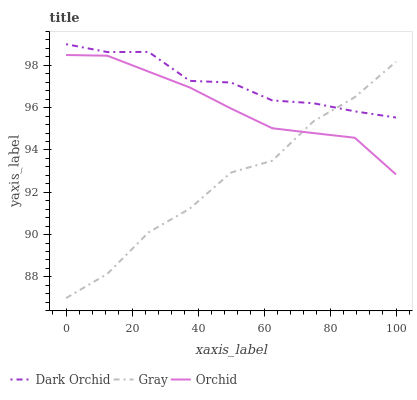Does Orchid have the minimum area under the curve?
Answer yes or no. No. Does Orchid have the maximum area under the curve?
Answer yes or no. No. Is Dark Orchid the smoothest?
Answer yes or no. No. Is Dark Orchid the roughest?
Answer yes or no. No. Does Orchid have the lowest value?
Answer yes or no. No. Does Orchid have the highest value?
Answer yes or no. No. Is Orchid less than Dark Orchid?
Answer yes or no. Yes. Is Dark Orchid greater than Orchid?
Answer yes or no. Yes. Does Orchid intersect Dark Orchid?
Answer yes or no. No. 